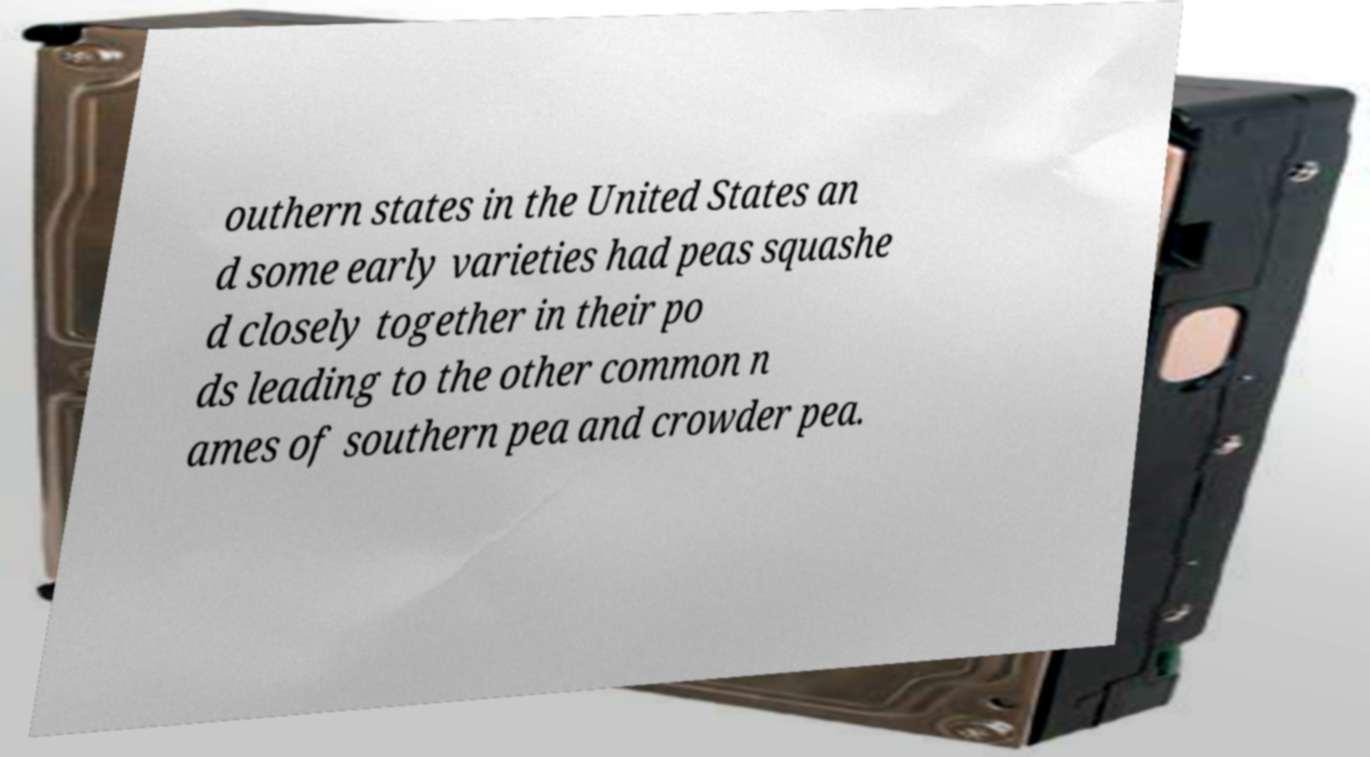Please identify and transcribe the text found in this image. outhern states in the United States an d some early varieties had peas squashe d closely together in their po ds leading to the other common n ames of southern pea and crowder pea. 